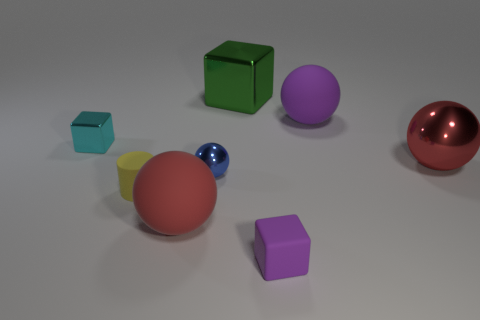Subtract all purple blocks. How many blocks are left? 2 Subtract all small metal cubes. How many cubes are left? 2 Subtract 2 cubes. How many cubes are left? 1 Add 2 balls. How many objects exist? 10 Subtract all cylinders. How many objects are left? 7 Add 4 big red rubber balls. How many big red rubber balls exist? 5 Subtract 1 purple spheres. How many objects are left? 7 Subtract all brown blocks. Subtract all gray cylinders. How many blocks are left? 3 Subtract all cyan cylinders. How many green cubes are left? 1 Subtract all small yellow objects. Subtract all small yellow cylinders. How many objects are left? 6 